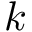<formula> <loc_0><loc_0><loc_500><loc_500>k</formula> 